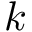<formula> <loc_0><loc_0><loc_500><loc_500>k</formula> 